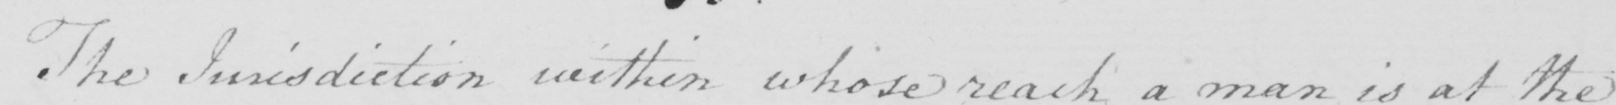What text is written in this handwritten line? The Jurisdiction within whose reach a man is at the 